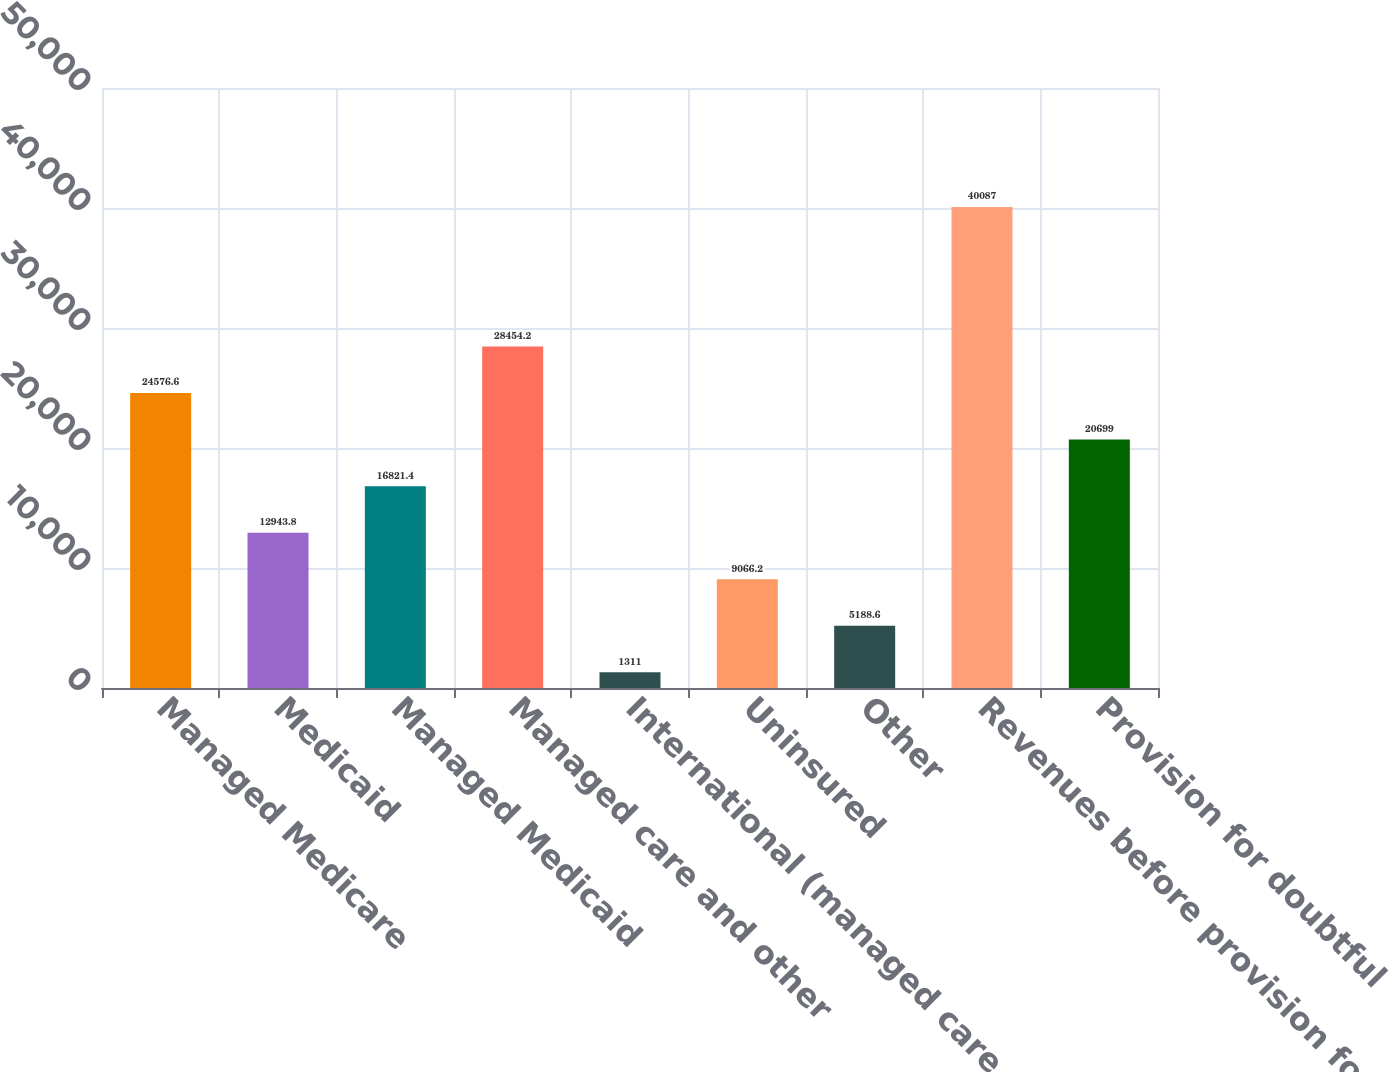Convert chart to OTSL. <chart><loc_0><loc_0><loc_500><loc_500><bar_chart><fcel>Managed Medicare<fcel>Medicaid<fcel>Managed Medicaid<fcel>Managed care and other<fcel>International (managed care<fcel>Uninsured<fcel>Other<fcel>Revenues before provision for<fcel>Provision for doubtful<nl><fcel>24576.6<fcel>12943.8<fcel>16821.4<fcel>28454.2<fcel>1311<fcel>9066.2<fcel>5188.6<fcel>40087<fcel>20699<nl></chart> 